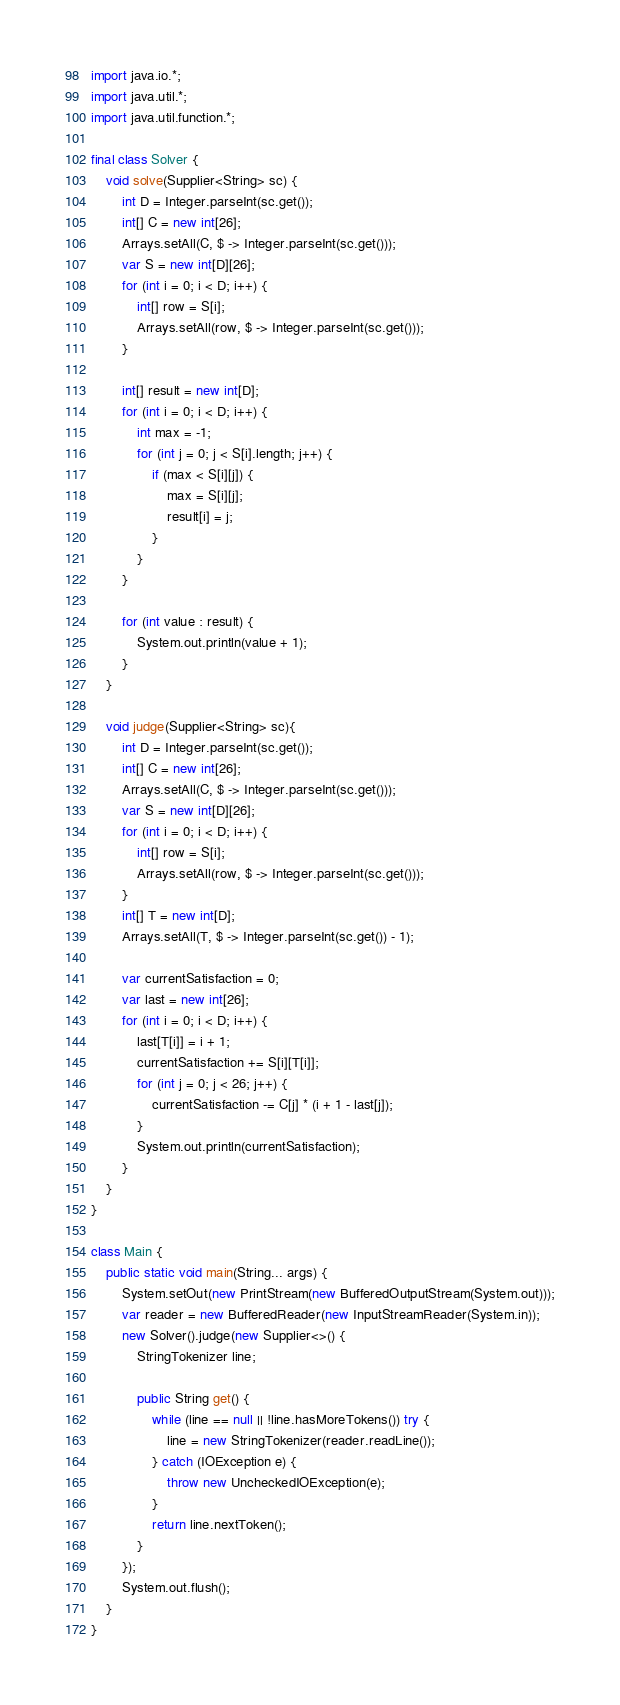Convert code to text. <code><loc_0><loc_0><loc_500><loc_500><_Java_>import java.io.*;
import java.util.*;
import java.util.function.*;

final class Solver {
	void solve(Supplier<String> sc) {
		int D = Integer.parseInt(sc.get());
		int[] C = new int[26];
		Arrays.setAll(C, $ -> Integer.parseInt(sc.get()));
		var S = new int[D][26];
		for (int i = 0; i < D; i++) {
			int[] row = S[i];
			Arrays.setAll(row, $ -> Integer.parseInt(sc.get()));
		}

		int[] result = new int[D];
		for (int i = 0; i < D; i++) {
			int max = -1;
			for (int j = 0; j < S[i].length; j++) {
				if (max < S[i][j]) {
					max = S[i][j];
					result[i] = j;
				}
			}
		}

		for (int value : result) {
			System.out.println(value + 1);
		}
	}

	void judge(Supplier<String> sc){
		int D = Integer.parseInt(sc.get());
		int[] C = new int[26];
		Arrays.setAll(C, $ -> Integer.parseInt(sc.get()));
		var S = new int[D][26];
		for (int i = 0; i < D; i++) {
			int[] row = S[i];
			Arrays.setAll(row, $ -> Integer.parseInt(sc.get()));
		}
		int[] T = new int[D];
		Arrays.setAll(T, $ -> Integer.parseInt(sc.get()) - 1);

		var currentSatisfaction = 0;
		var last = new int[26];
		for (int i = 0; i < D; i++) {
			last[T[i]] = i + 1;
			currentSatisfaction += S[i][T[i]];
			for (int j = 0; j < 26; j++) {
				currentSatisfaction -= C[j] * (i + 1 - last[j]);
			}
			System.out.println(currentSatisfaction);
		}
	}
}

class Main {
	public static void main(String... args) {
		System.setOut(new PrintStream(new BufferedOutputStream(System.out)));
		var reader = new BufferedReader(new InputStreamReader(System.in));
		new Solver().judge(new Supplier<>() {
			StringTokenizer line;

			public String get() {
				while (line == null || !line.hasMoreTokens()) try {
					line = new StringTokenizer(reader.readLine());
				} catch (IOException e) {
					throw new UncheckedIOException(e);
				}
				return line.nextToken();
			}
		});
		System.out.flush();
	}
}</code> 